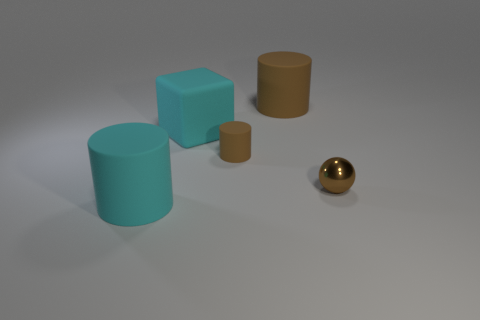Is there anything else that has the same material as the ball?
Provide a succinct answer. No. Is there a tiny cylinder that is to the left of the large rubber cylinder in front of the large cyan rubber block?
Your answer should be compact. No. Is the size of the rubber cube the same as the thing that is in front of the tiny brown sphere?
Your answer should be compact. Yes. Is there a cyan object that is to the right of the large thing right of the big cyan rubber thing behind the ball?
Your answer should be compact. No. There is a big cylinder that is in front of the small metallic thing; what is it made of?
Your answer should be very brief. Rubber. Do the matte block and the cyan rubber cylinder have the same size?
Your answer should be compact. Yes. The cylinder that is in front of the big cyan block and behind the small brown metallic ball is what color?
Provide a succinct answer. Brown. What shape is the cyan thing that is made of the same material as the large cyan cylinder?
Your answer should be very brief. Cube. What number of objects are both in front of the big block and right of the big rubber block?
Your answer should be very brief. 2. Are there any brown rubber cylinders to the right of the small brown shiny thing?
Ensure brevity in your answer.  No. 